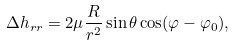<formula> <loc_0><loc_0><loc_500><loc_500>\Delta h _ { r r } = 2 \mu \frac { R } { r ^ { 2 } } \sin \theta \cos ( \varphi - \varphi _ { 0 } ) ,</formula> 